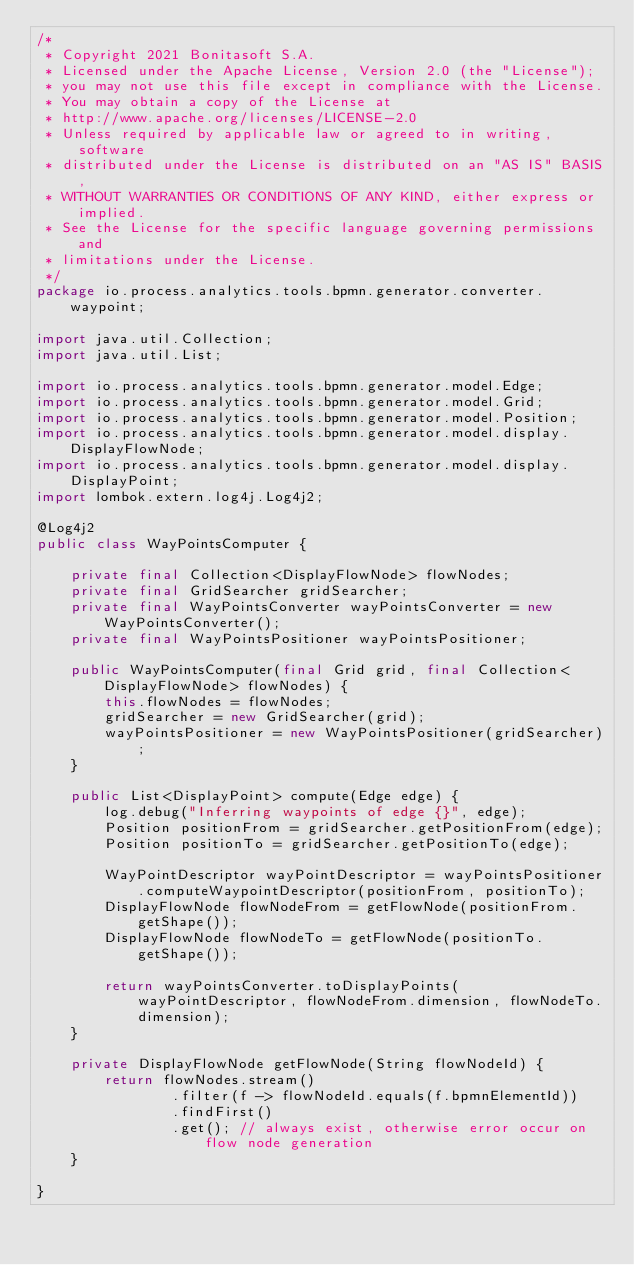Convert code to text. <code><loc_0><loc_0><loc_500><loc_500><_Java_>/*
 * Copyright 2021 Bonitasoft S.A.
 * Licensed under the Apache License, Version 2.0 (the "License");
 * you may not use this file except in compliance with the License.
 * You may obtain a copy of the License at
 * http://www.apache.org/licenses/LICENSE-2.0
 * Unless required by applicable law or agreed to in writing, software
 * distributed under the License is distributed on an "AS IS" BASIS,
 * WITHOUT WARRANTIES OR CONDITIONS OF ANY KIND, either express or implied.
 * See the License for the specific language governing permissions and
 * limitations under the License.
 */
package io.process.analytics.tools.bpmn.generator.converter.waypoint;

import java.util.Collection;
import java.util.List;

import io.process.analytics.tools.bpmn.generator.model.Edge;
import io.process.analytics.tools.bpmn.generator.model.Grid;
import io.process.analytics.tools.bpmn.generator.model.Position;
import io.process.analytics.tools.bpmn.generator.model.display.DisplayFlowNode;
import io.process.analytics.tools.bpmn.generator.model.display.DisplayPoint;
import lombok.extern.log4j.Log4j2;

@Log4j2
public class WayPointsComputer {

    private final Collection<DisplayFlowNode> flowNodes;
    private final GridSearcher gridSearcher;
    private final WayPointsConverter wayPointsConverter = new WayPointsConverter();
    private final WayPointsPositioner wayPointsPositioner;

    public WayPointsComputer(final Grid grid, final Collection<DisplayFlowNode> flowNodes) {
        this.flowNodes = flowNodes;
        gridSearcher = new GridSearcher(grid);
        wayPointsPositioner = new WayPointsPositioner(gridSearcher);
    }

    public List<DisplayPoint> compute(Edge edge) {
        log.debug("Inferring waypoints of edge {}", edge);
        Position positionFrom = gridSearcher.getPositionFrom(edge);
        Position positionTo = gridSearcher.getPositionTo(edge);

        WayPointDescriptor wayPointDescriptor = wayPointsPositioner.computeWaypointDescriptor(positionFrom, positionTo);
        DisplayFlowNode flowNodeFrom = getFlowNode(positionFrom.getShape());
        DisplayFlowNode flowNodeTo = getFlowNode(positionTo.getShape());

        return wayPointsConverter.toDisplayPoints(wayPointDescriptor, flowNodeFrom.dimension, flowNodeTo.dimension);
    }

    private DisplayFlowNode getFlowNode(String flowNodeId) {
        return flowNodes.stream()
                .filter(f -> flowNodeId.equals(f.bpmnElementId))
                .findFirst()
                .get(); // always exist, otherwise error occur on flow node generation
    }

}
</code> 